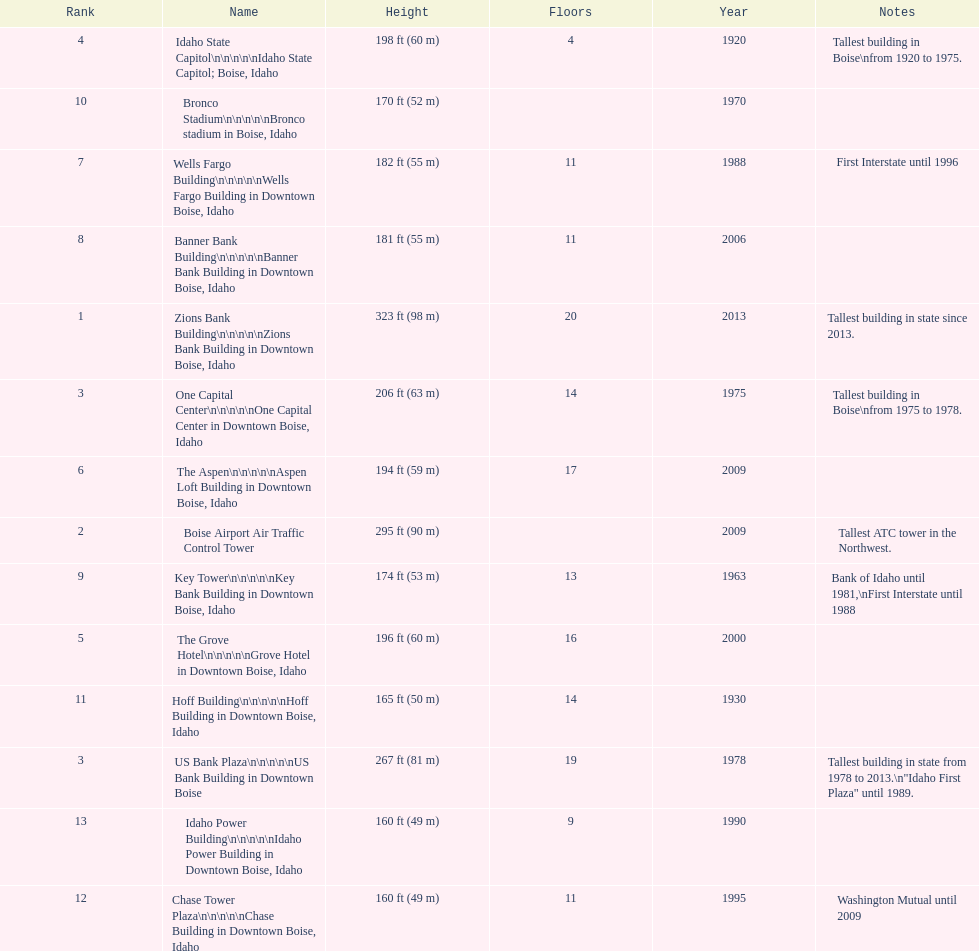Is the bronco stadium above or below 150 ft? Above. 